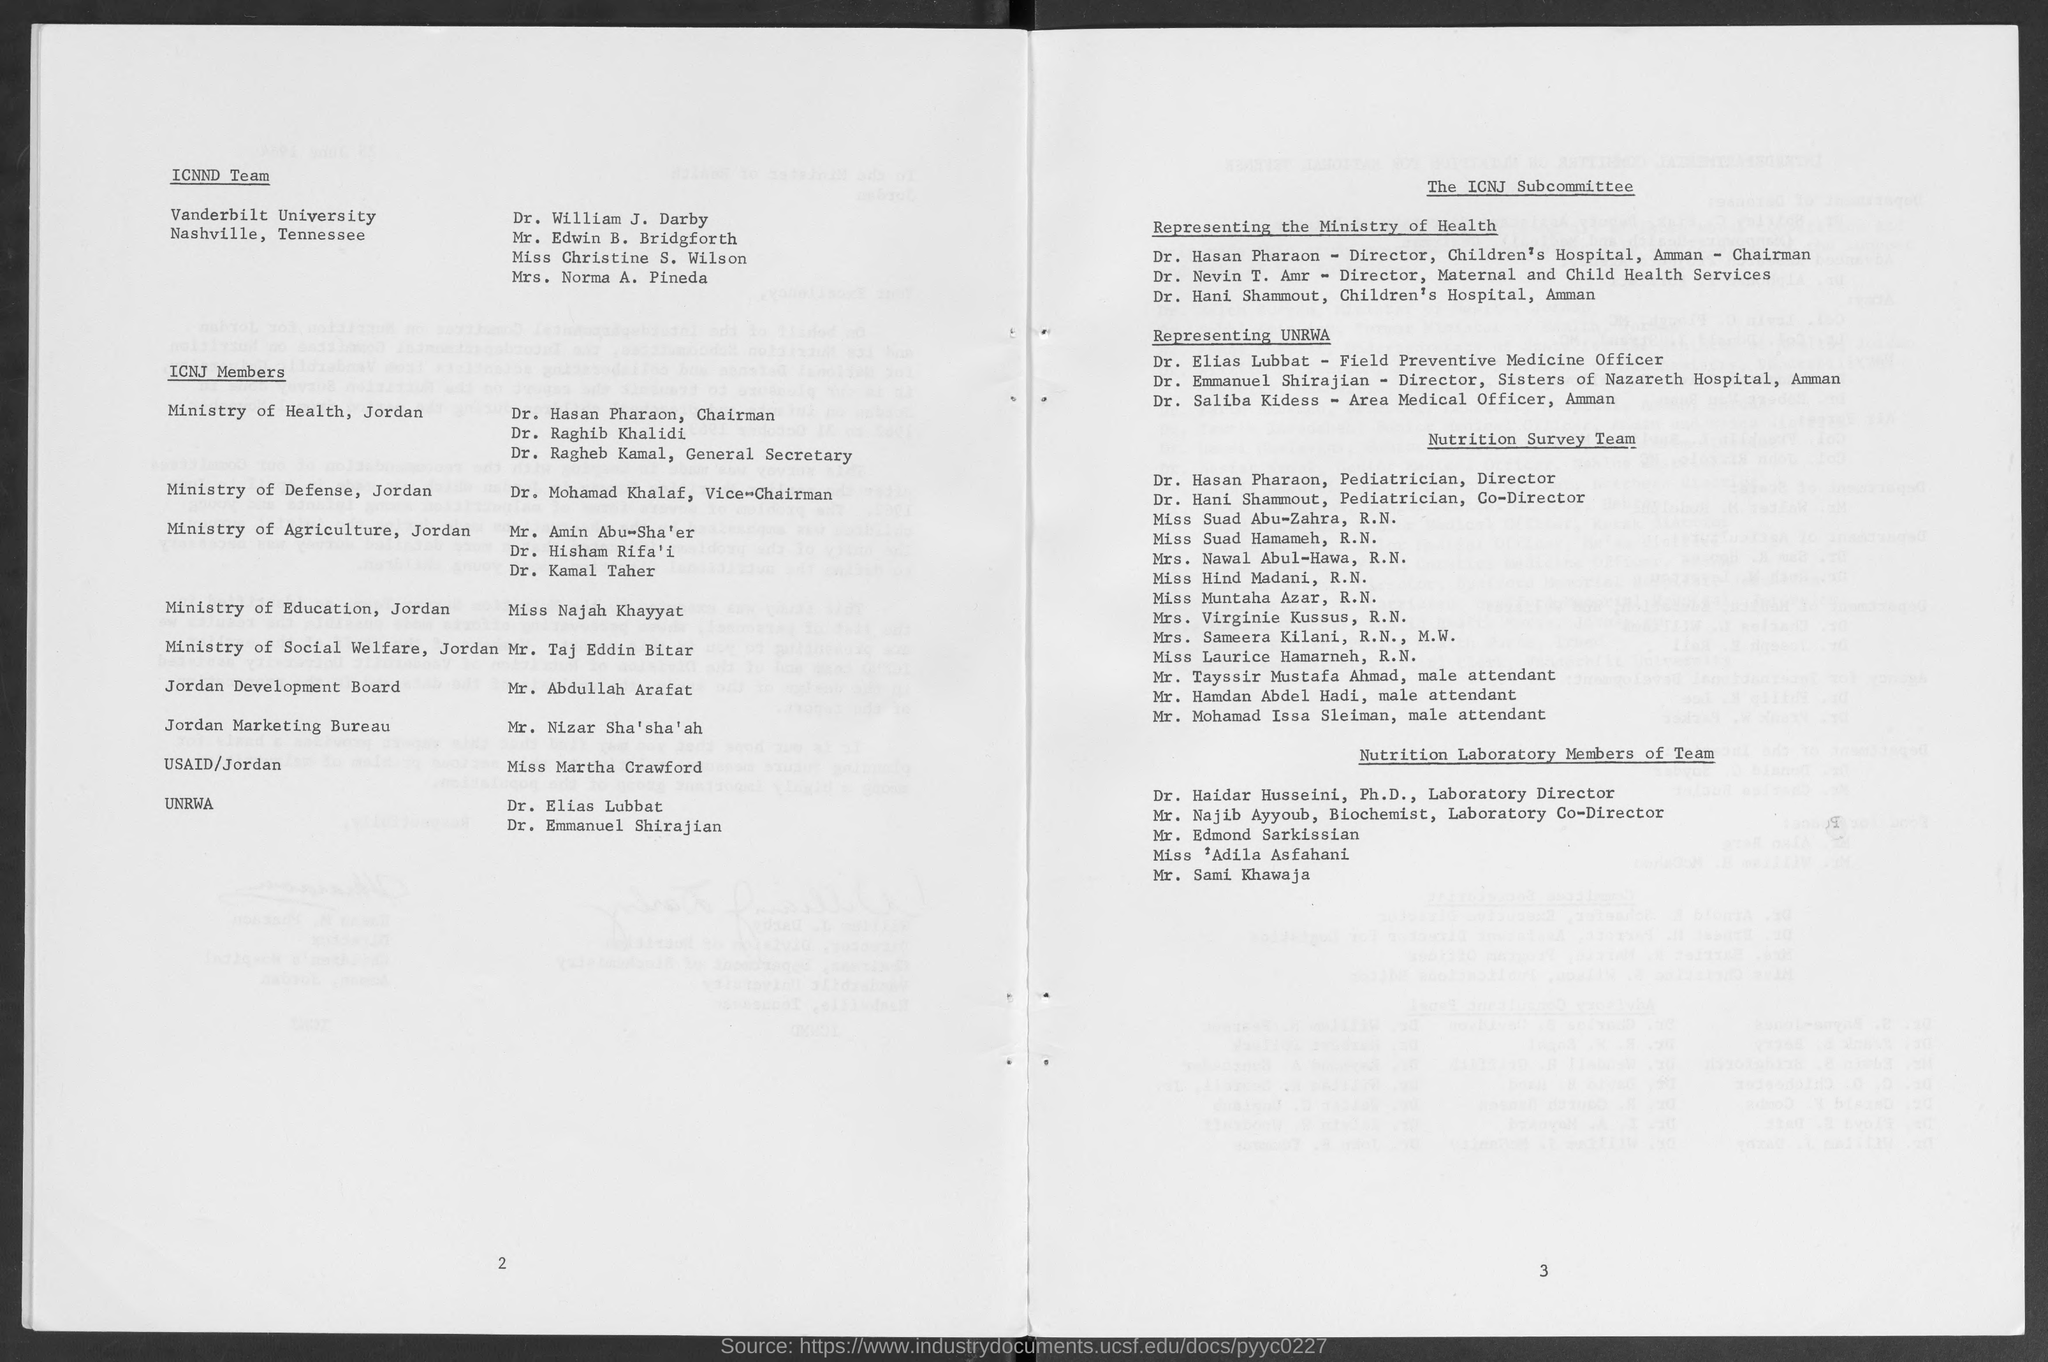List a handful of essential elements in this visual. The General Secretary of the Ministry of Health is Dr. Ragheb Kamal. Dr. Nevin T. Amr is the Director of Maternal and Child Health Services. The Vice-Chairman of the Ministry of Defense in Jordan is Dr. Mohamad Khalaf. Dr. Hasan Pharaon is the chairman of the Ministry of Health in Jordan. The director of the Children's Hospital in Amman is Dr. Hasan Pharaon, who serves as the chairman. 